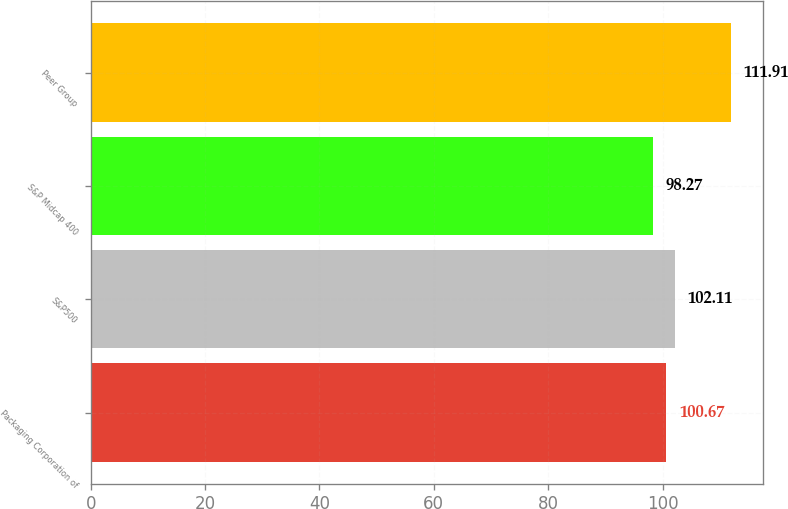Convert chart. <chart><loc_0><loc_0><loc_500><loc_500><bar_chart><fcel>Packaging Corporation of<fcel>S&P500<fcel>S&P Midcap 400<fcel>Peer Group<nl><fcel>100.67<fcel>102.11<fcel>98.27<fcel>111.91<nl></chart> 